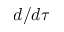Convert formula to latex. <formula><loc_0><loc_0><loc_500><loc_500>d / d \tau</formula> 